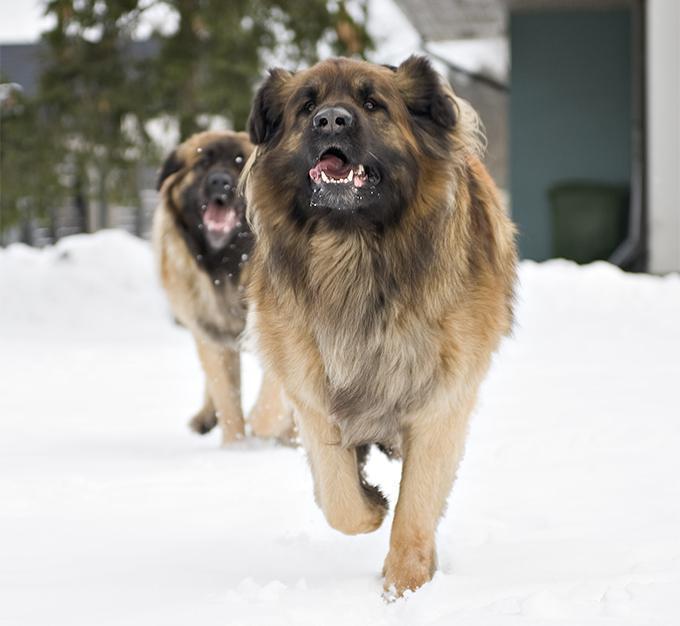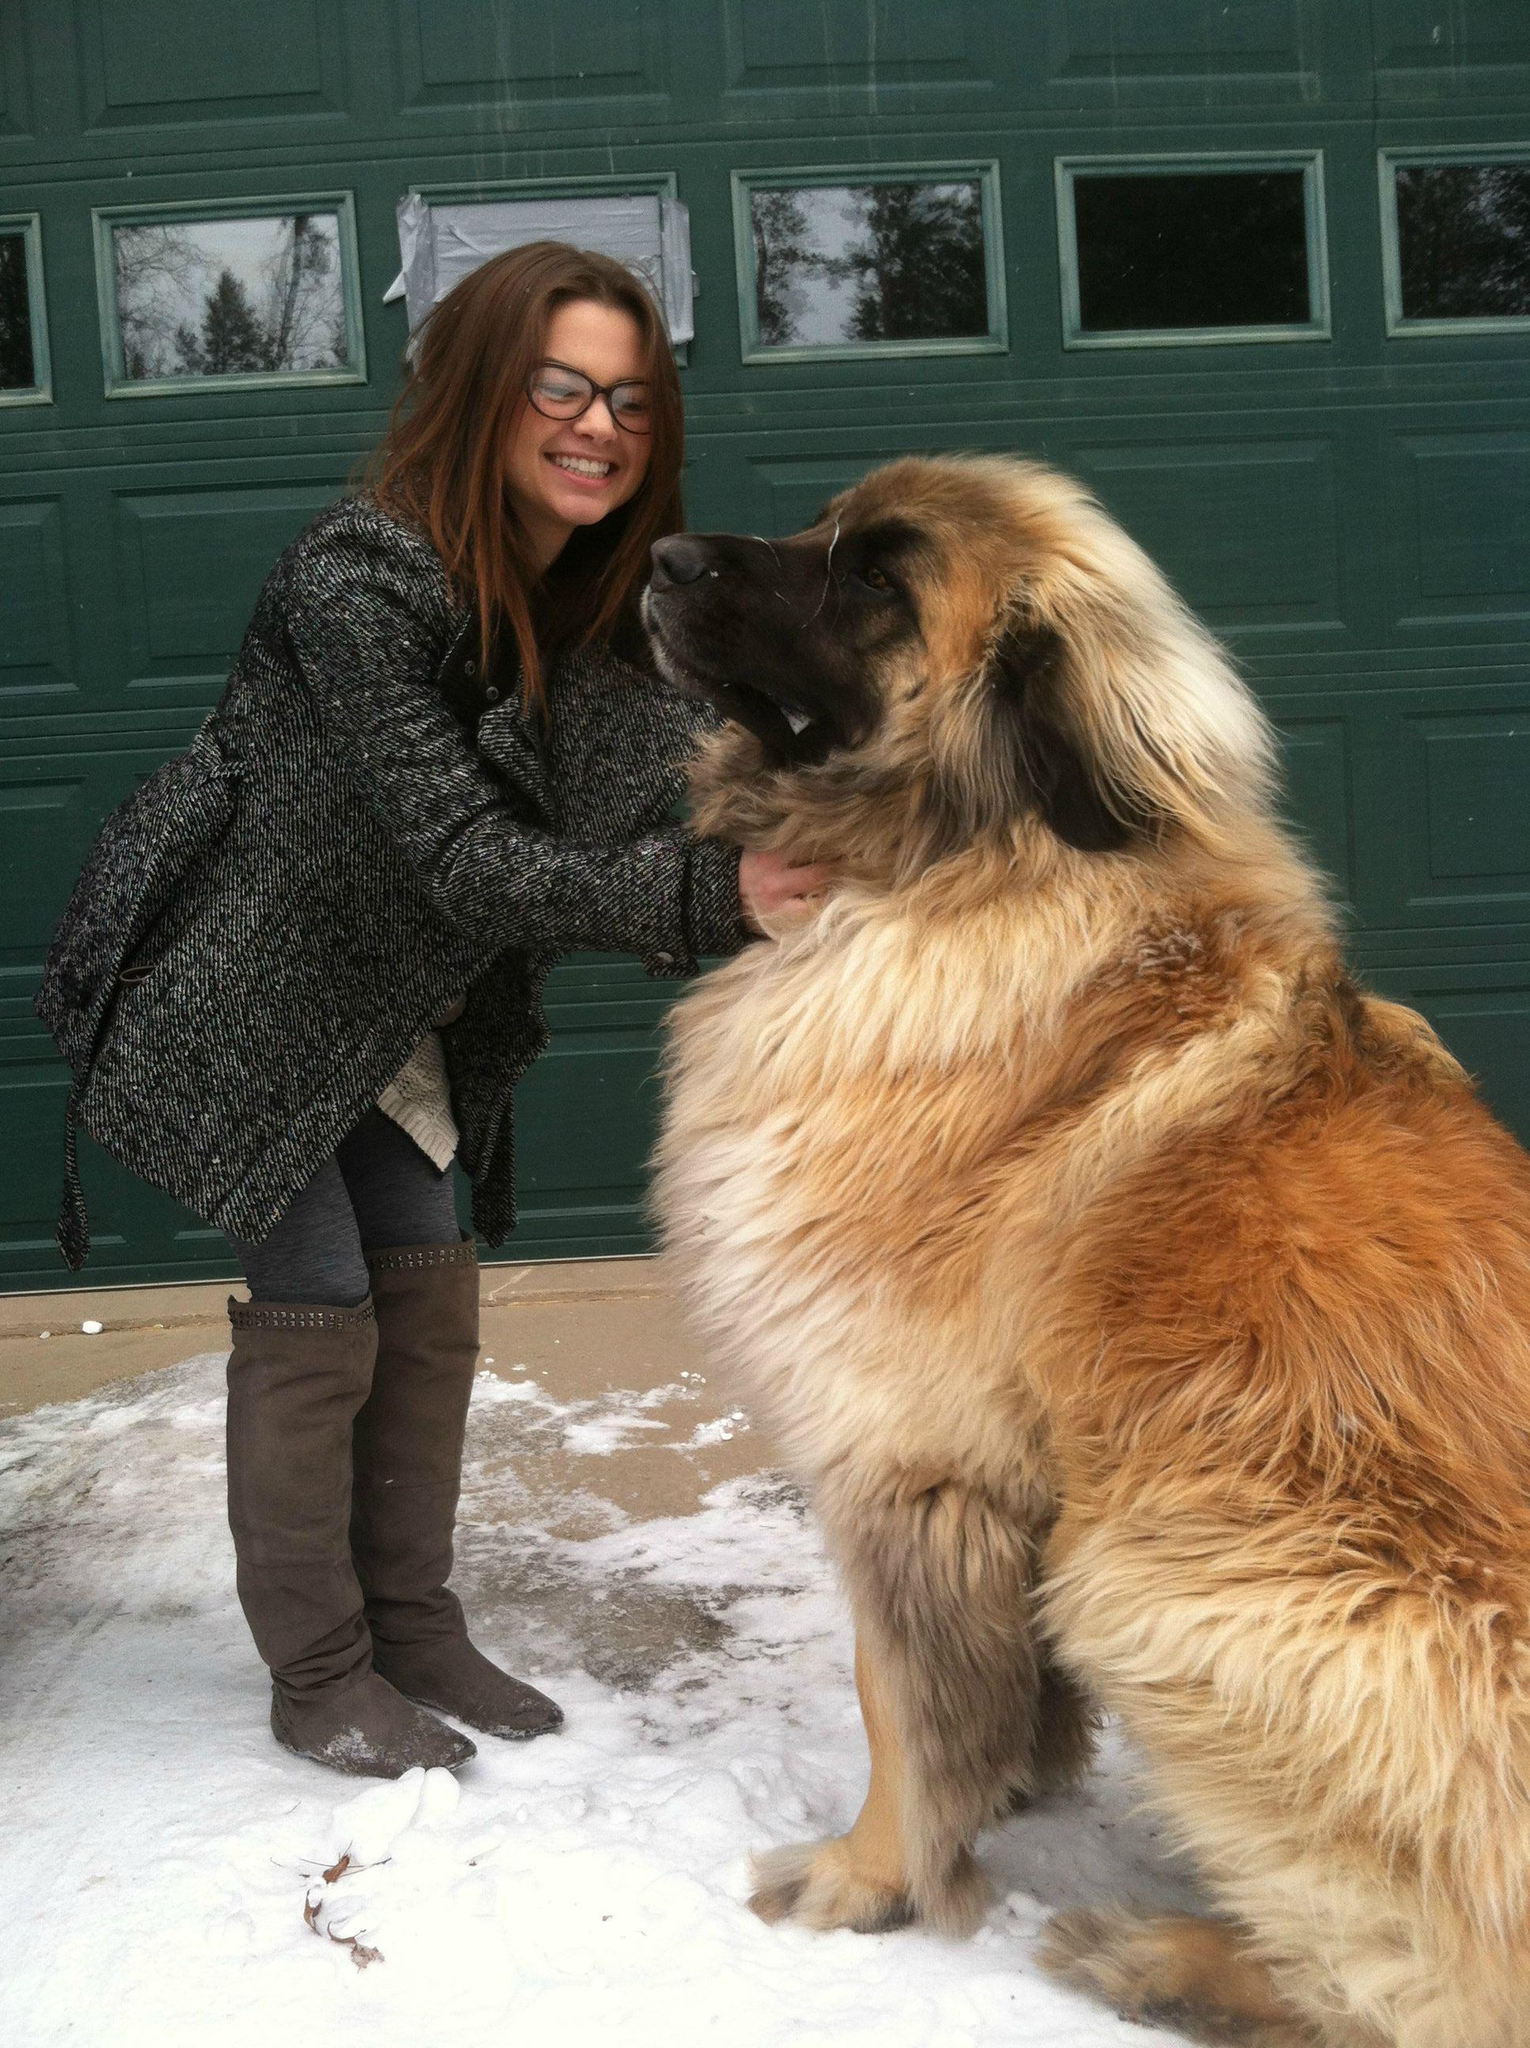The first image is the image on the left, the second image is the image on the right. Analyze the images presented: Is the assertion "There is a small child playing with a big dog." valid? Answer yes or no. No. 